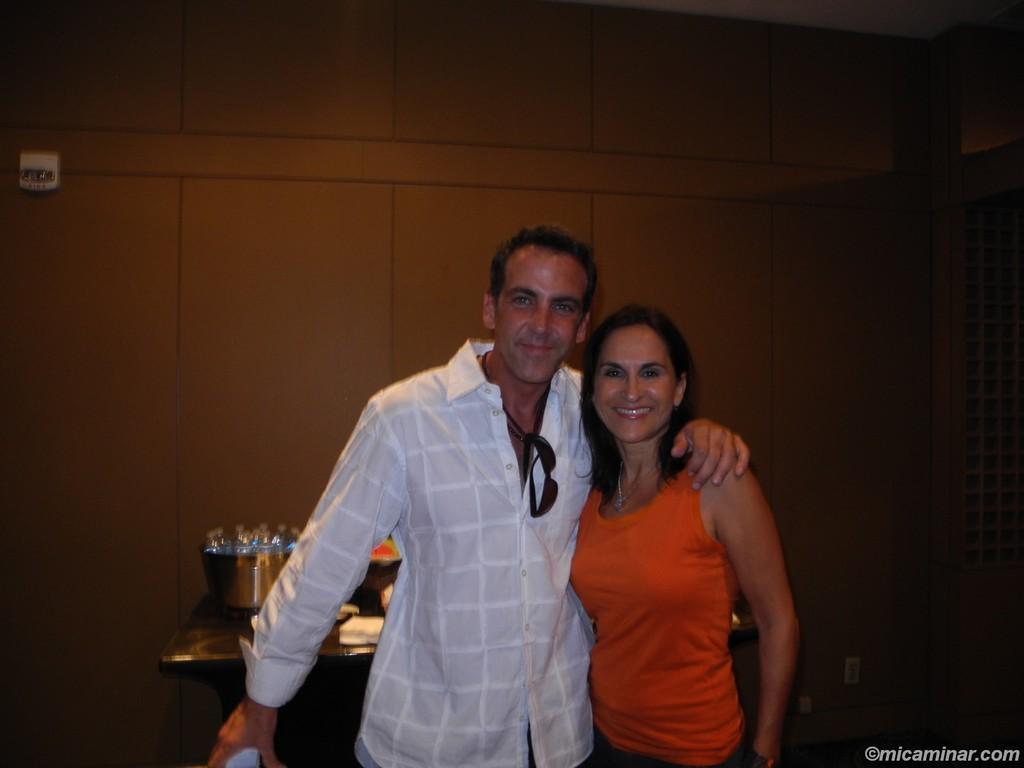Can you describe this image briefly? In this image we can see a lady, and a man, we can see sunglasses on him, there are some objects on the table, also we can see the wall. 